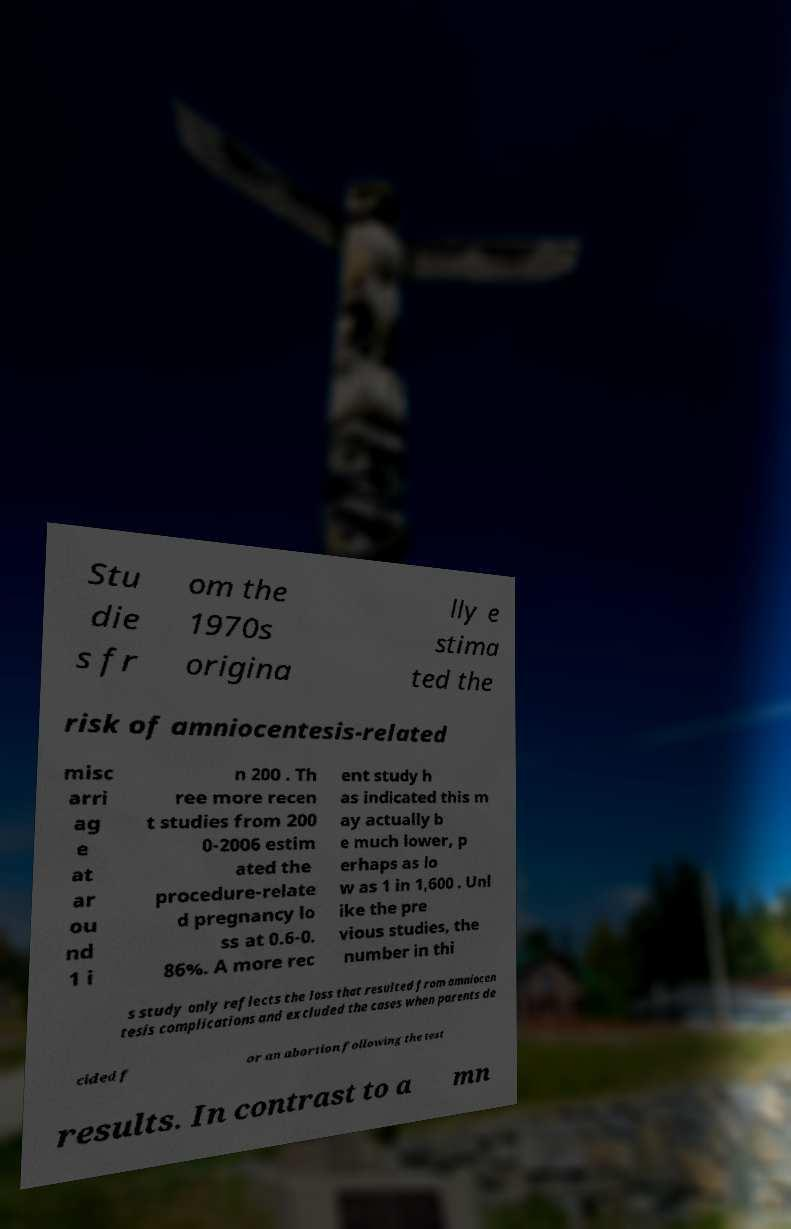Could you extract and type out the text from this image? Stu die s fr om the 1970s origina lly e stima ted the risk of amniocentesis-related misc arri ag e at ar ou nd 1 i n 200 . Th ree more recen t studies from 200 0-2006 estim ated the procedure-relate d pregnancy lo ss at 0.6-0. 86%. A more rec ent study h as indicated this m ay actually b e much lower, p erhaps as lo w as 1 in 1,600 . Unl ike the pre vious studies, the number in thi s study only reflects the loss that resulted from amniocen tesis complications and excluded the cases when parents de cided f or an abortion following the test results. In contrast to a mn 